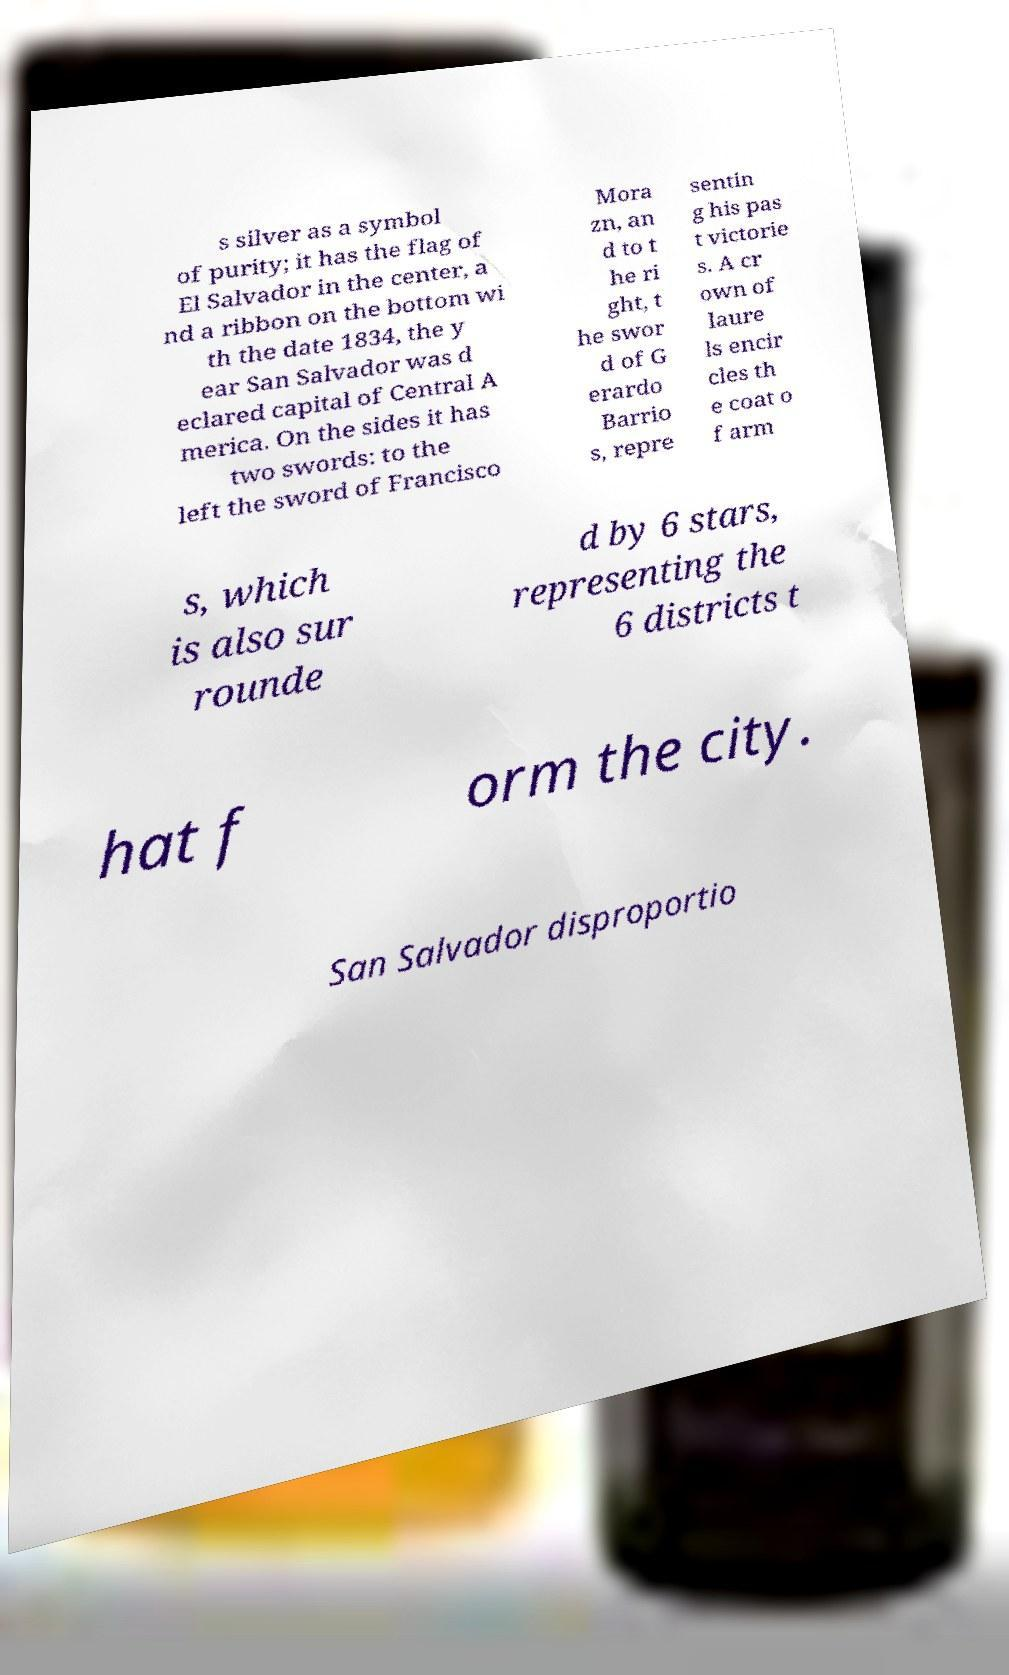Can you read and provide the text displayed in the image?This photo seems to have some interesting text. Can you extract and type it out for me? s silver as a symbol of purity; it has the flag of El Salvador in the center, a nd a ribbon on the bottom wi th the date 1834, the y ear San Salvador was d eclared capital of Central A merica. On the sides it has two swords: to the left the sword of Francisco Mora zn, an d to t he ri ght, t he swor d of G erardo Barrio s, repre sentin g his pas t victorie s. A cr own of laure ls encir cles th e coat o f arm s, which is also sur rounde d by 6 stars, representing the 6 districts t hat f orm the city. San Salvador disproportio 